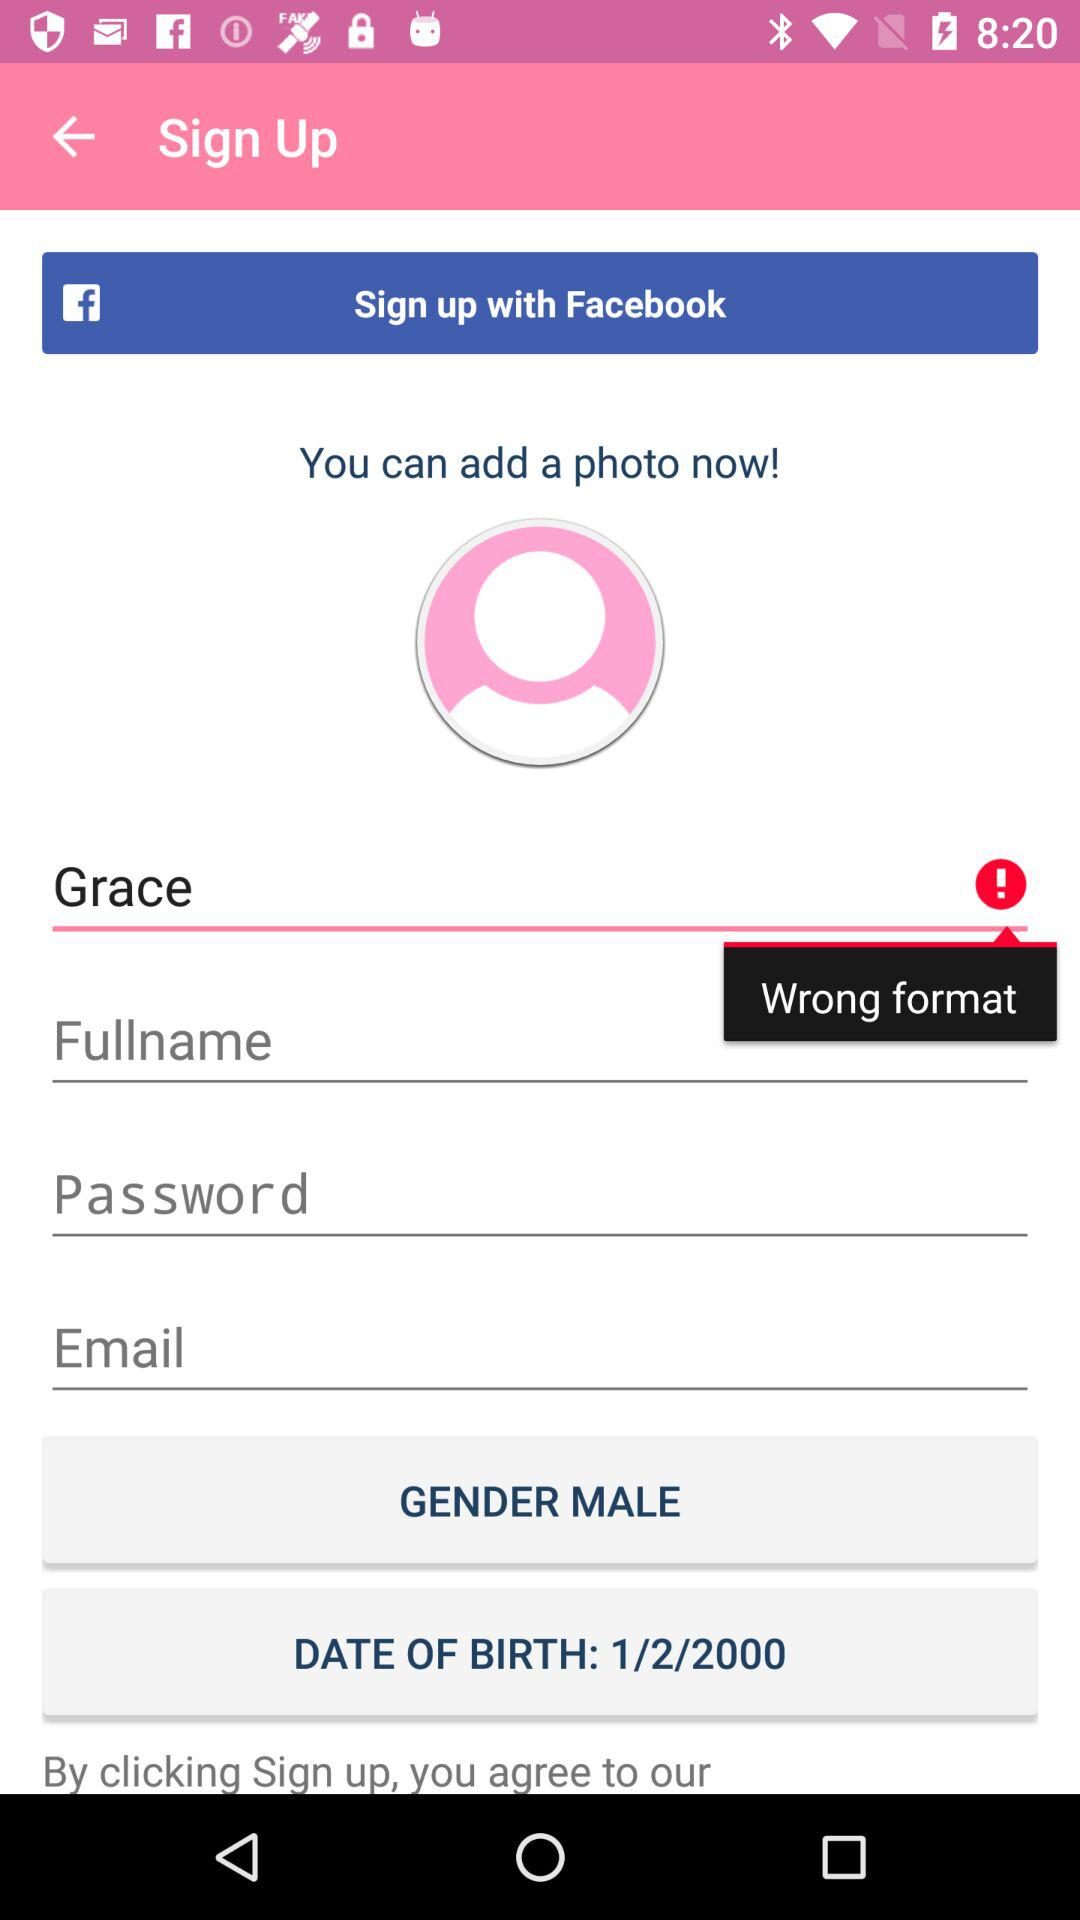What is the date of birth? The date of birth is January 2, 2000. 